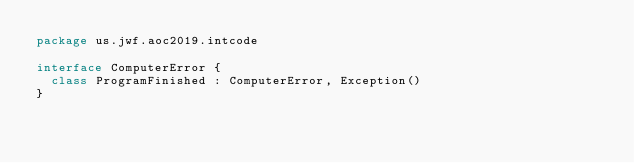Convert code to text. <code><loc_0><loc_0><loc_500><loc_500><_Kotlin_>package us.jwf.aoc2019.intcode

interface ComputerError {
  class ProgramFinished : ComputerError, Exception()
}</code> 